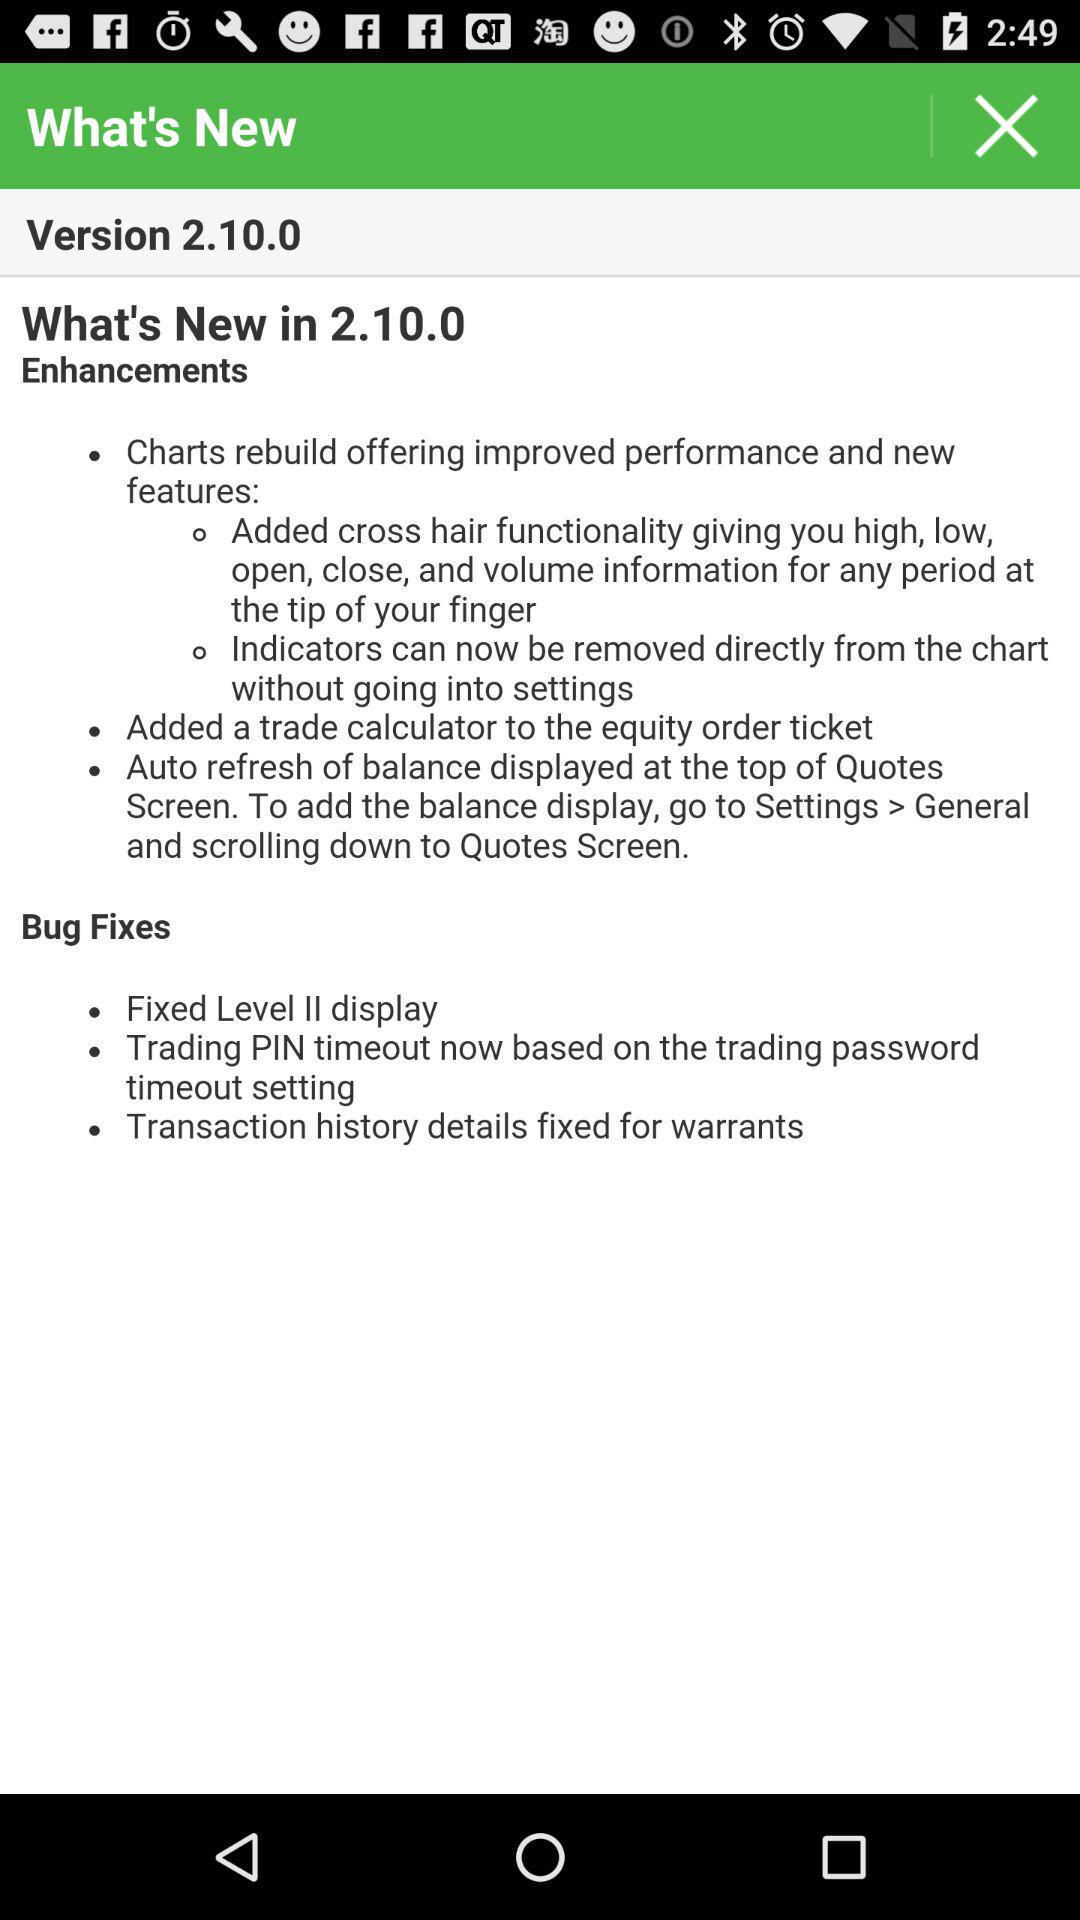What are the bug fixes? The bug fixes are "Fixed Level II display", "Trading PIN timeout now based on the trading password timeout setting" and "Transaction history details fixed for warrants". 